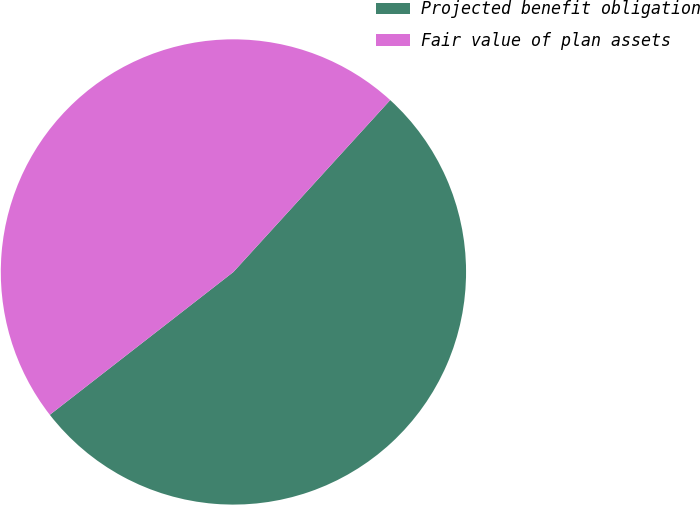Convert chart. <chart><loc_0><loc_0><loc_500><loc_500><pie_chart><fcel>Projected benefit obligation<fcel>Fair value of plan assets<nl><fcel>52.71%<fcel>47.29%<nl></chart> 